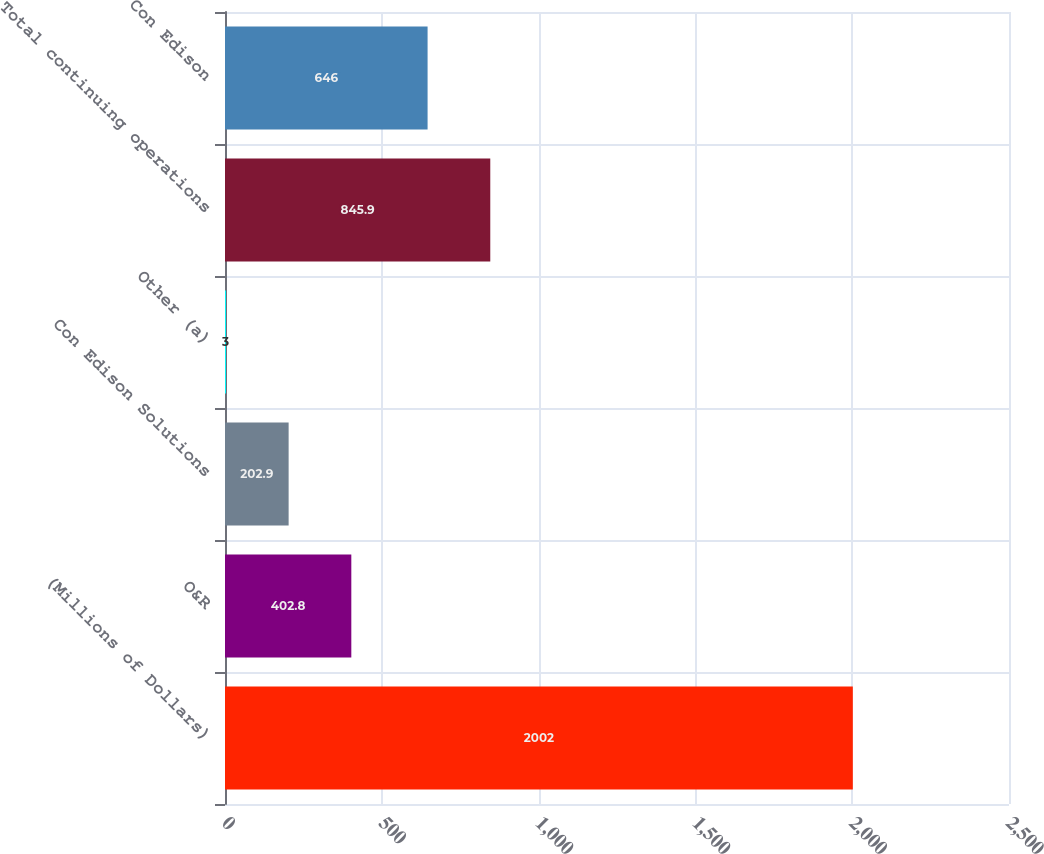Convert chart to OTSL. <chart><loc_0><loc_0><loc_500><loc_500><bar_chart><fcel>(Millions of Dollars)<fcel>O&R<fcel>Con Edison Solutions<fcel>Other (a)<fcel>Total continuing operations<fcel>Con Edison<nl><fcel>2002<fcel>402.8<fcel>202.9<fcel>3<fcel>845.9<fcel>646<nl></chart> 